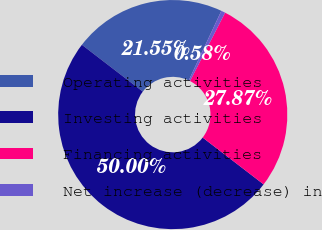<chart> <loc_0><loc_0><loc_500><loc_500><pie_chart><fcel>Operating activities<fcel>Investing activities<fcel>Financing activities<fcel>Net increase (decrease) in<nl><fcel>21.55%<fcel>50.0%<fcel>27.87%<fcel>0.58%<nl></chart> 